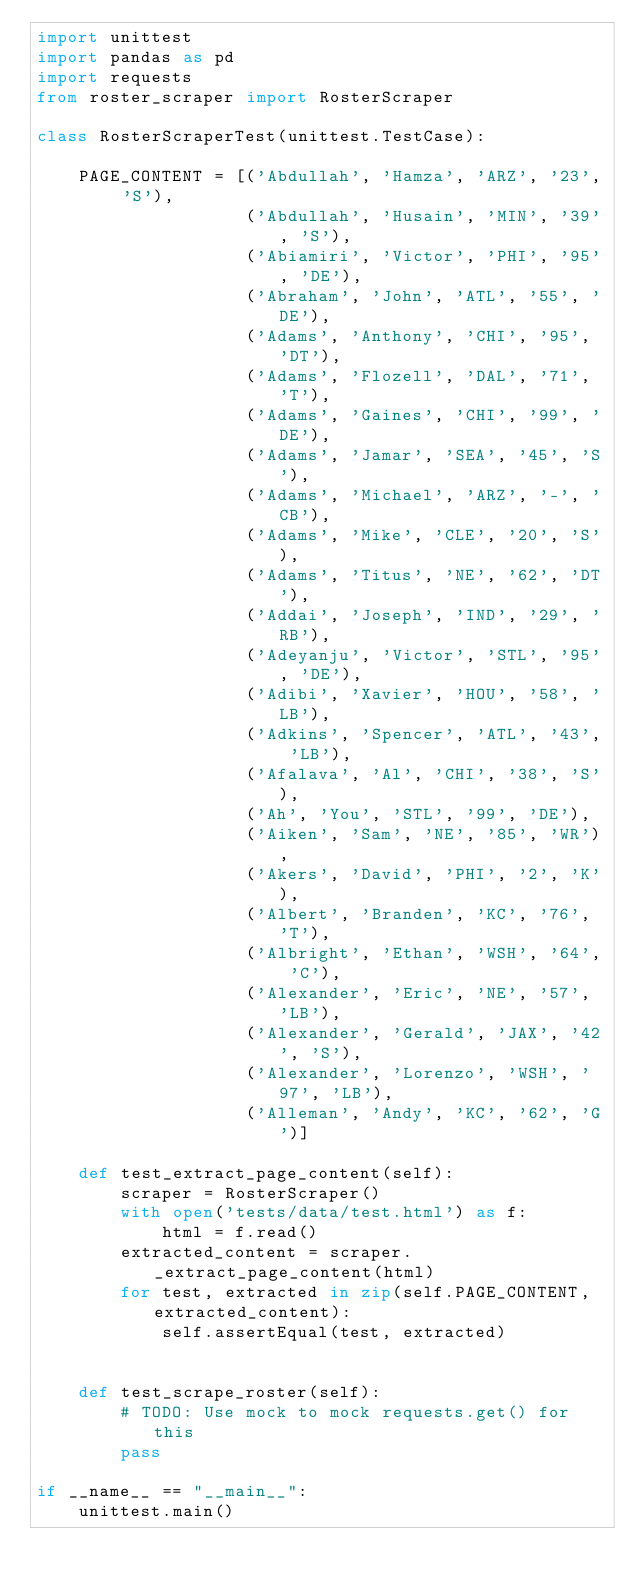<code> <loc_0><loc_0><loc_500><loc_500><_Python_>import unittest
import pandas as pd
import requests
from roster_scraper import RosterScraper

class RosterScraperTest(unittest.TestCase):

    PAGE_CONTENT = [('Abdullah', 'Hamza', 'ARZ', '23', 'S'),
                    ('Abdullah', 'Husain', 'MIN', '39', 'S'),
                    ('Abiamiri', 'Victor', 'PHI', '95', 'DE'),
                    ('Abraham', 'John', 'ATL', '55', 'DE'),
                    ('Adams', 'Anthony', 'CHI', '95', 'DT'),
                    ('Adams', 'Flozell', 'DAL', '71', 'T'),
                    ('Adams', 'Gaines', 'CHI', '99', 'DE'),
                    ('Adams', 'Jamar', 'SEA', '45', 'S'),
                    ('Adams', 'Michael', 'ARZ', '-', 'CB'),
                    ('Adams', 'Mike', 'CLE', '20', 'S'),
                    ('Adams', 'Titus', 'NE', '62', 'DT'),
                    ('Addai', 'Joseph', 'IND', '29', 'RB'),
                    ('Adeyanju', 'Victor', 'STL', '95', 'DE'),
                    ('Adibi', 'Xavier', 'HOU', '58', 'LB'),
                    ('Adkins', 'Spencer', 'ATL', '43', 'LB'),
                    ('Afalava', 'Al', 'CHI', '38', 'S'),
                    ('Ah', 'You', 'STL', '99', 'DE'),
                    ('Aiken', 'Sam', 'NE', '85', 'WR'),
                    ('Akers', 'David', 'PHI', '2', 'K'),
                    ('Albert', 'Branden', 'KC', '76', 'T'),
                    ('Albright', 'Ethan', 'WSH', '64', 'C'),
                    ('Alexander', 'Eric', 'NE', '57', 'LB'),
                    ('Alexander', 'Gerald', 'JAX', '42', 'S'),
                    ('Alexander', 'Lorenzo', 'WSH', '97', 'LB'),
                    ('Alleman', 'Andy', 'KC', '62', 'G')]

    def test_extract_page_content(self):
        scraper = RosterScraper()
        with open('tests/data/test.html') as f:
            html = f.read()
        extracted_content = scraper._extract_page_content(html)
        for test, extracted in zip(self.PAGE_CONTENT, extracted_content):
            self.assertEqual(test, extracted)


    def test_scrape_roster(self):
        # TODO: Use mock to mock requests.get() for this
        pass

if __name__ == "__main__":
    unittest.main()
</code> 